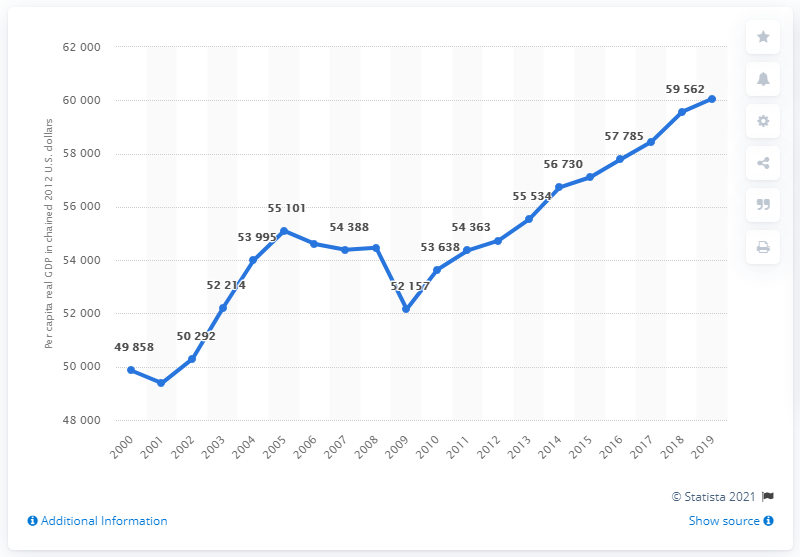Outline some significant characteristics in this image. In 2012, the per capita real GDP of Minnesota was 60,066 chained. 